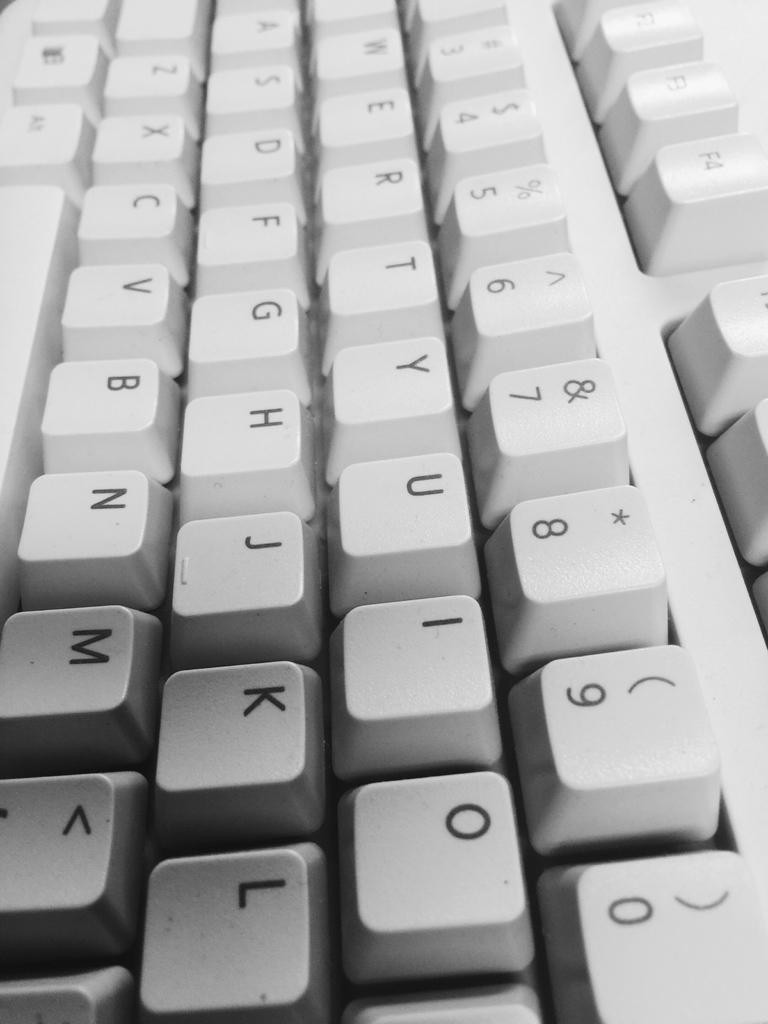<image>
Render a clear and concise summary of the photo. A standard computer key board with the letter U I O in the first row. 